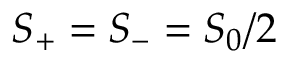Convert formula to latex. <formula><loc_0><loc_0><loc_500><loc_500>S _ { + } = S _ { - } = S _ { 0 } / 2</formula> 